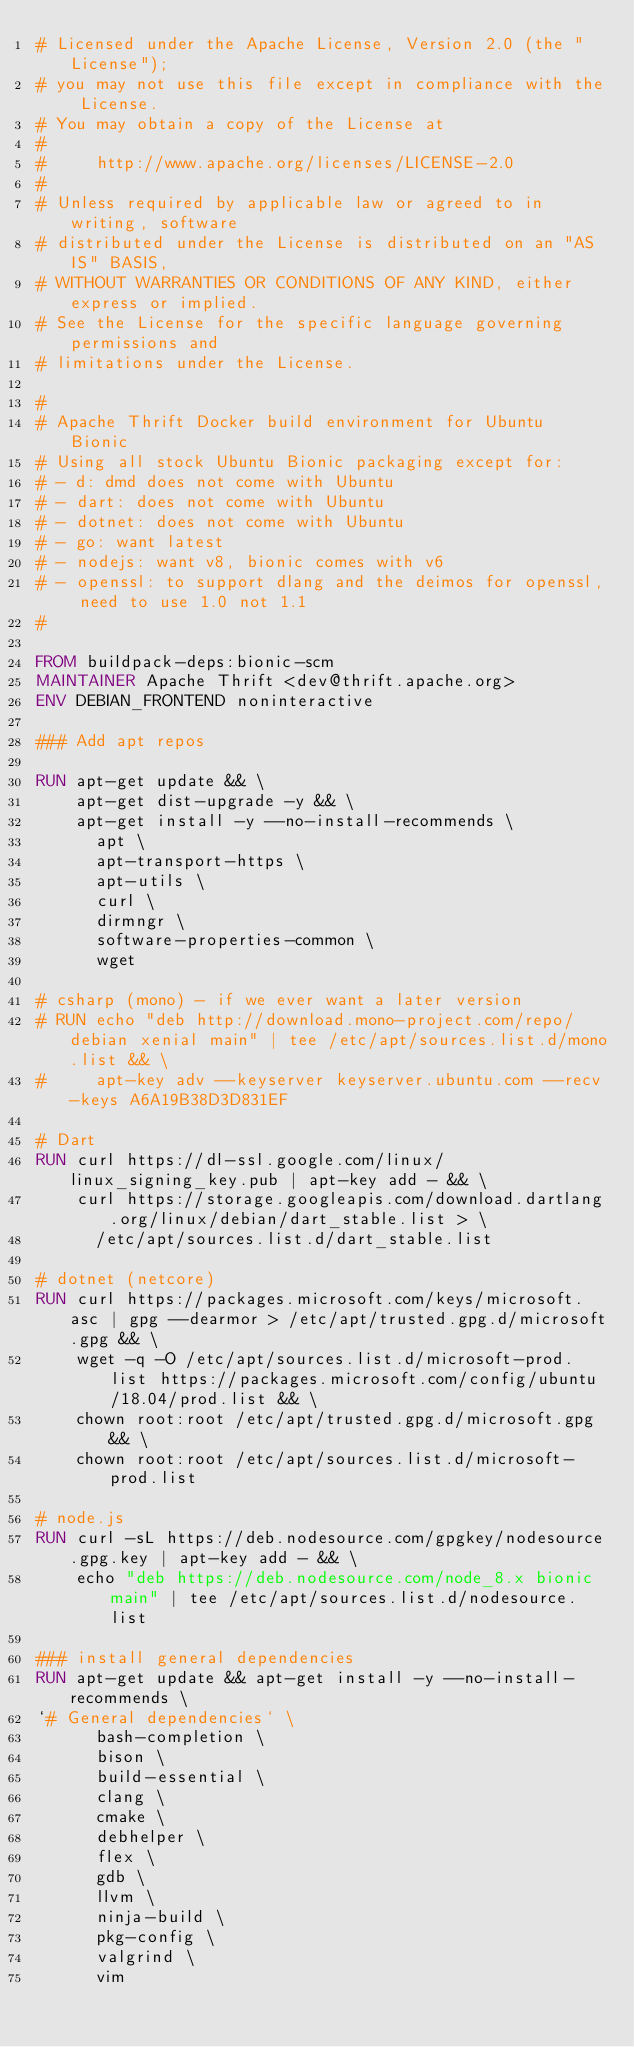<code> <loc_0><loc_0><loc_500><loc_500><_Dockerfile_># Licensed under the Apache License, Version 2.0 (the "License");
# you may not use this file except in compliance with the License.
# You may obtain a copy of the License at
#
#     http://www.apache.org/licenses/LICENSE-2.0
#
# Unless required by applicable law or agreed to in writing, software
# distributed under the License is distributed on an "AS IS" BASIS,
# WITHOUT WARRANTIES OR CONDITIONS OF ANY KIND, either express or implied.
# See the License for the specific language governing permissions and
# limitations under the License.

#
# Apache Thrift Docker build environment for Ubuntu Bionic
# Using all stock Ubuntu Bionic packaging except for:
# - d: dmd does not come with Ubuntu
# - dart: does not come with Ubuntu
# - dotnet: does not come with Ubuntu
# - go: want latest
# - nodejs: want v8, bionic comes with v6
# - openssl: to support dlang and the deimos for openssl, need to use 1.0 not 1.1
#

FROM buildpack-deps:bionic-scm
MAINTAINER Apache Thrift <dev@thrift.apache.org>
ENV DEBIAN_FRONTEND noninteractive

### Add apt repos

RUN apt-get update && \
    apt-get dist-upgrade -y && \
    apt-get install -y --no-install-recommends \
      apt \
      apt-transport-https \
      apt-utils \
      curl \
      dirmngr \
      software-properties-common \
      wget

# csharp (mono) - if we ever want a later version
# RUN echo "deb http://download.mono-project.com/repo/debian xenial main" | tee /etc/apt/sources.list.d/mono.list && \
#     apt-key adv --keyserver keyserver.ubuntu.com --recv-keys A6A19B38D3D831EF

# Dart
RUN curl https://dl-ssl.google.com/linux/linux_signing_key.pub | apt-key add - && \
    curl https://storage.googleapis.com/download.dartlang.org/linux/debian/dart_stable.list > \
      /etc/apt/sources.list.d/dart_stable.list

# dotnet (netcore)
RUN curl https://packages.microsoft.com/keys/microsoft.asc | gpg --dearmor > /etc/apt/trusted.gpg.d/microsoft.gpg && \
    wget -q -O /etc/apt/sources.list.d/microsoft-prod.list https://packages.microsoft.com/config/ubuntu/18.04/prod.list && \
    chown root:root /etc/apt/trusted.gpg.d/microsoft.gpg && \
    chown root:root /etc/apt/sources.list.d/microsoft-prod.list

# node.js
RUN curl -sL https://deb.nodesource.com/gpgkey/nodesource.gpg.key | apt-key add - && \
    echo "deb https://deb.nodesource.com/node_8.x bionic main" | tee /etc/apt/sources.list.d/nodesource.list

### install general dependencies
RUN apt-get update && apt-get install -y --no-install-recommends \
`# General dependencies` \
      bash-completion \
      bison \
      build-essential \
      clang \
      cmake \
      debhelper \
      flex \
      gdb \
      llvm \
      ninja-build \
      pkg-config \
      valgrind \
      vim</code> 